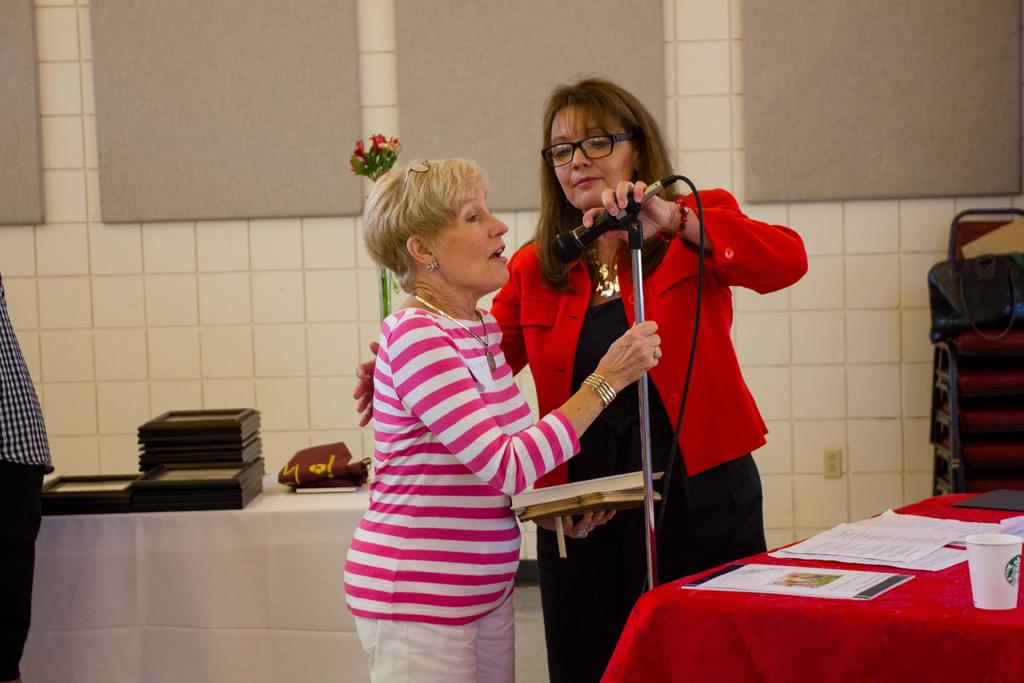What is the main subject of the image? The main subject of the image is women. Can you describe the position of the women in the image? The women are standing in the image. What object is one of the women holding in her hand? One of the women is holding a mic in her hand. Is there any blood visible on the women or the mic in the image? There is no blood visible on the women or the mic in the image. What type of cork is being used by the women in the image? There is no cork present in the image. Can you see any hoses connected to the mic in the image? There are no hoses visible in the image. 